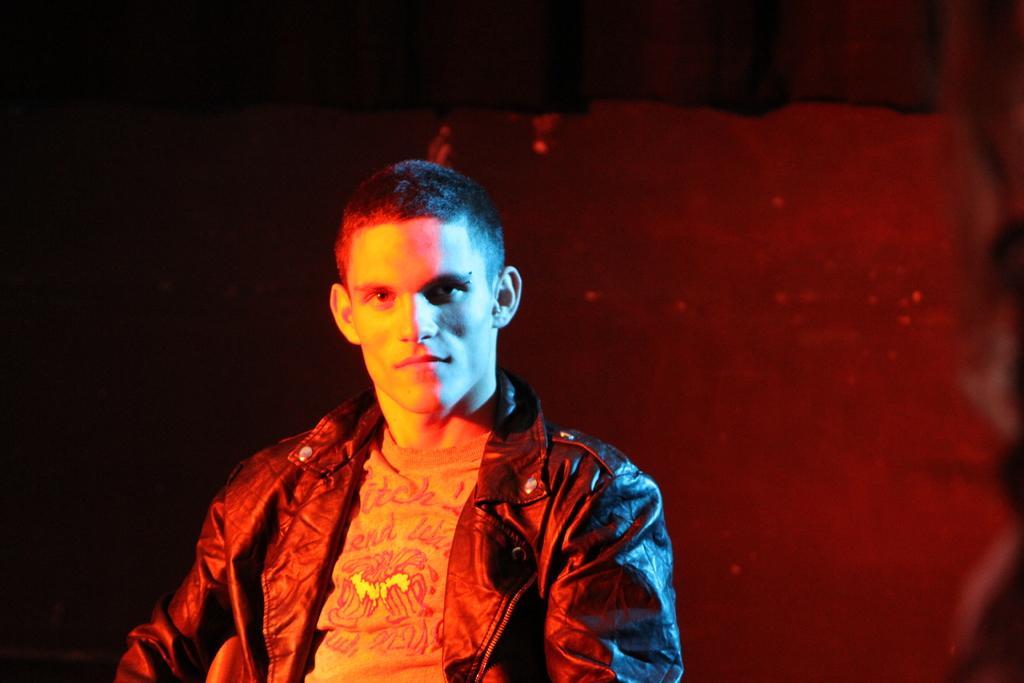How would you summarize this image in a sentence or two? In this image there is a person, in the background it is dark and blurred. 